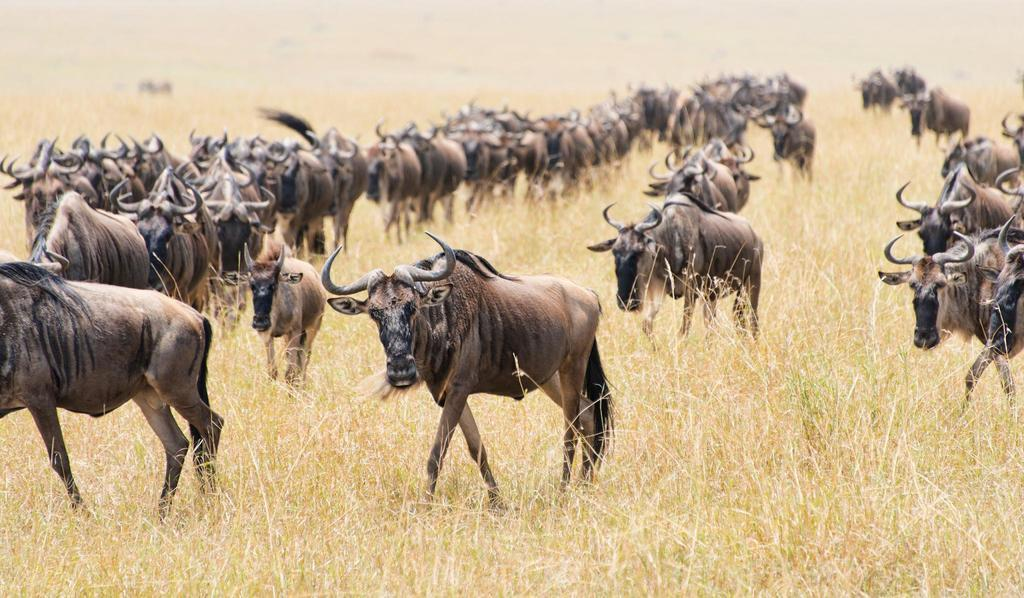What animals can be seen on the ground in the image? There is a group of wildebeests on the ground in the image. What type of vegetation is visible in the image? There is grass visible in the image. Can you describe the background of the image? The background of the image is blurry. What type of camera can be seen in the image? There is no camera present in the image. What holiday is being celebrated in the image? There is no indication of a holiday being celebrated in the image. 